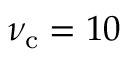<formula> <loc_0><loc_0><loc_500><loc_500>\nu _ { c } = 1 0</formula> 